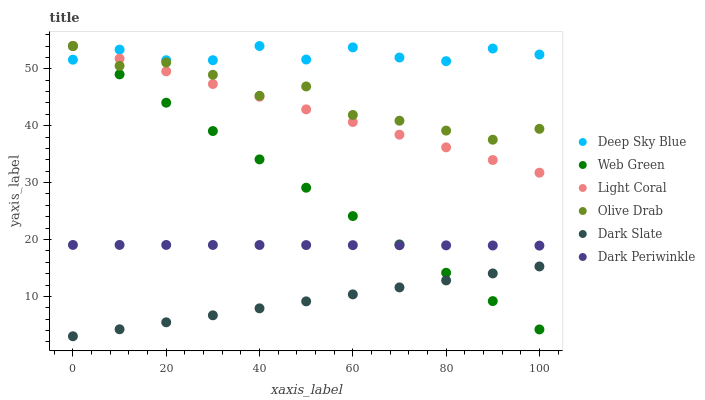Does Dark Slate have the minimum area under the curve?
Answer yes or no. Yes. Does Deep Sky Blue have the maximum area under the curve?
Answer yes or no. Yes. Does Light Coral have the minimum area under the curve?
Answer yes or no. No. Does Light Coral have the maximum area under the curve?
Answer yes or no. No. Is Web Green the smoothest?
Answer yes or no. Yes. Is Olive Drab the roughest?
Answer yes or no. Yes. Is Light Coral the smoothest?
Answer yes or no. No. Is Light Coral the roughest?
Answer yes or no. No. Does Dark Slate have the lowest value?
Answer yes or no. Yes. Does Light Coral have the lowest value?
Answer yes or no. No. Does Olive Drab have the highest value?
Answer yes or no. Yes. Does Dark Slate have the highest value?
Answer yes or no. No. Is Dark Periwinkle less than Light Coral?
Answer yes or no. Yes. Is Olive Drab greater than Dark Periwinkle?
Answer yes or no. Yes. Does Deep Sky Blue intersect Web Green?
Answer yes or no. Yes. Is Deep Sky Blue less than Web Green?
Answer yes or no. No. Is Deep Sky Blue greater than Web Green?
Answer yes or no. No. Does Dark Periwinkle intersect Light Coral?
Answer yes or no. No. 